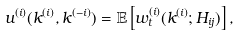<formula> <loc_0><loc_0><loc_500><loc_500>u ^ { ( i ) } ( k ^ { ( i ) } , k ^ { ( - i ) } ) = \mathbb { E } \left [ w _ { t } ^ { ( i ) } ( k ^ { ( i ) } ; H _ { i j } ) \right ] ,</formula> 